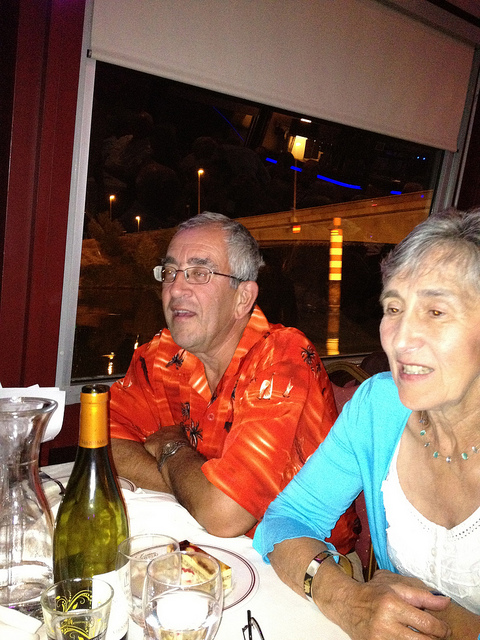What is the woman in the image doing? The woman in the image appears to be sitting at the dinner table, possibly engaged in conversation or listening to someone. She is wearing a light blue cardigan over a white top. 